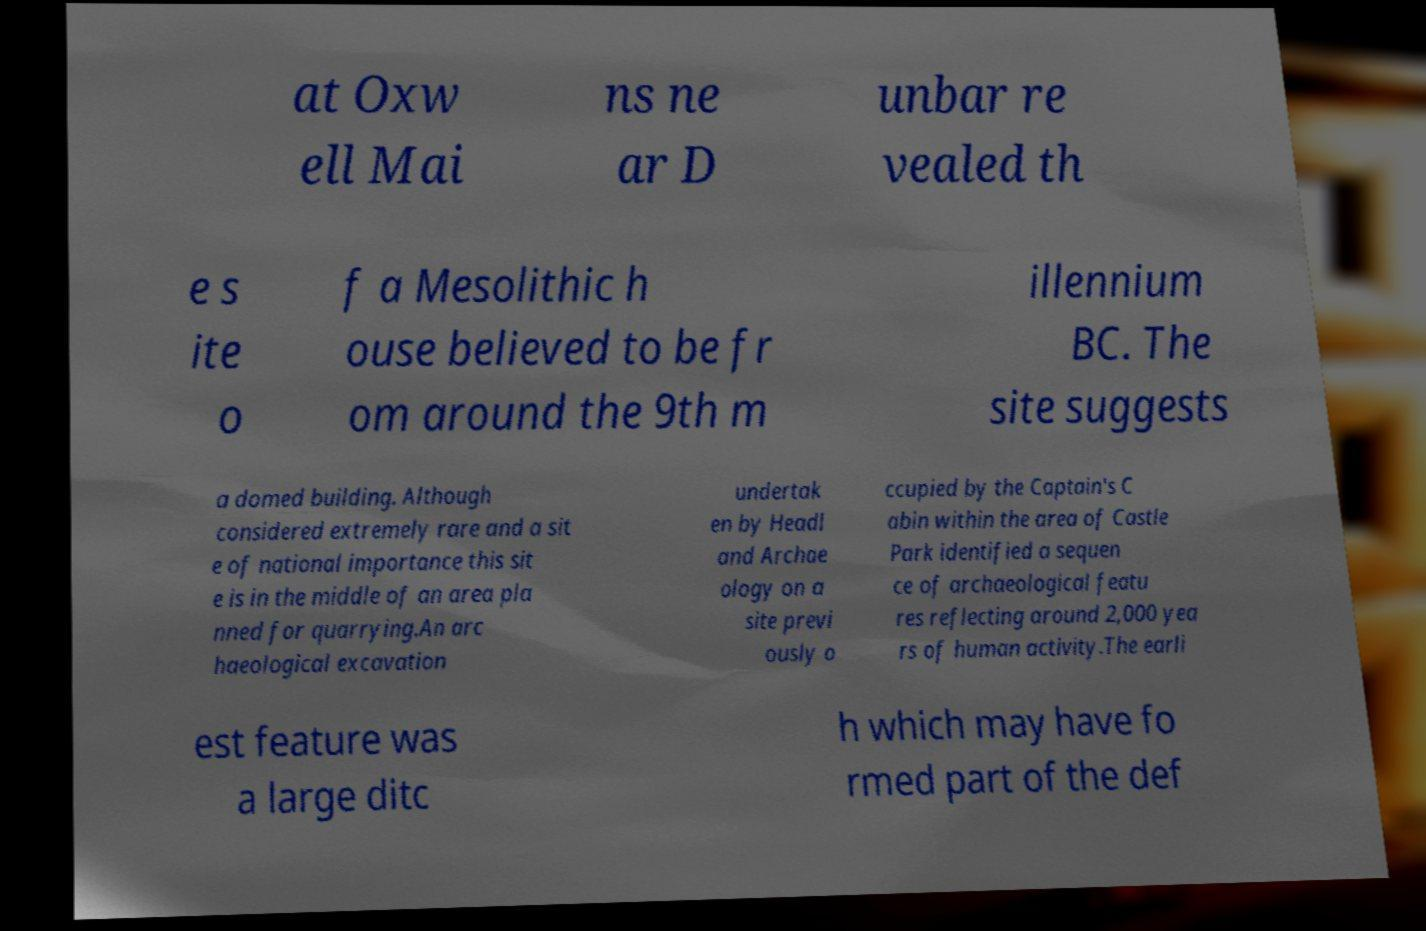I need the written content from this picture converted into text. Can you do that? at Oxw ell Mai ns ne ar D unbar re vealed th e s ite o f a Mesolithic h ouse believed to be fr om around the 9th m illennium BC. The site suggests a domed building. Although considered extremely rare and a sit e of national importance this sit e is in the middle of an area pla nned for quarrying.An arc haeological excavation undertak en by Headl and Archae ology on a site previ ously o ccupied by the Captain's C abin within the area of Castle Park identified a sequen ce of archaeological featu res reflecting around 2,000 yea rs of human activity.The earli est feature was a large ditc h which may have fo rmed part of the def 